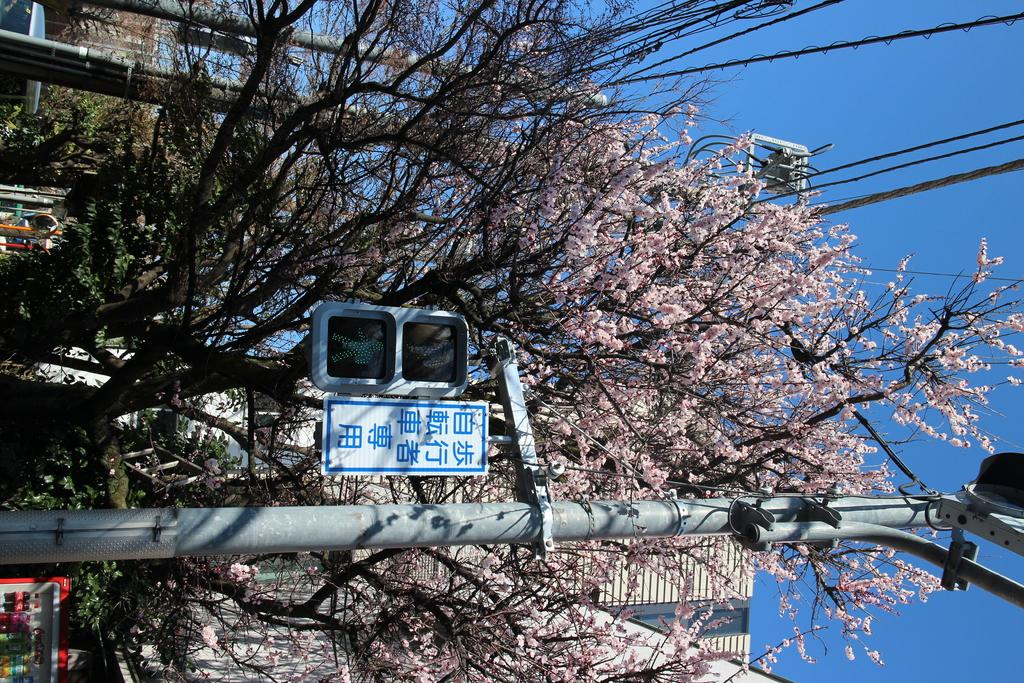What structure can be seen in the image? There is a light pole in the image. What type of natural elements are present in the image? There are trees in the image. What else can be seen in the image besides the light pole and trees? There are wires and buildings in the image. What part of the sky is visible in the image? The sky is visible on the right side of the image. When was the image taken? The image was taken during the day. What degree of temperature can be observed in the image? The image does not provide information about the temperature, so it cannot be determined from the image. How many planes are flying in the image? There are no planes visible in the image. 